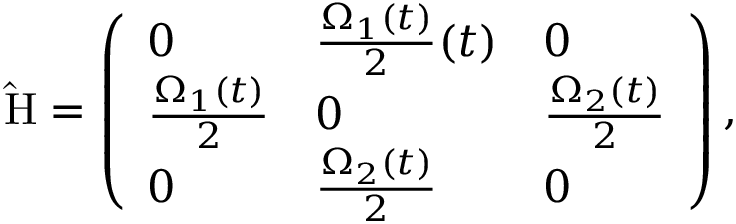<formula> <loc_0><loc_0><loc_500><loc_500>\hat { H } = \left ( \begin{array} { l l l } { 0 } & { \frac { \Omega _ { 1 } ( t ) } { 2 } ( t ) } & { 0 } \\ { \frac { \Omega _ { 1 } ( t ) } { 2 } } & { 0 } & { \frac { \Omega _ { 2 } ( t ) } { 2 } } \\ { 0 } & { \frac { \Omega _ { 2 } ( t ) } { 2 } } & { 0 } \end{array} \right ) ,</formula> 